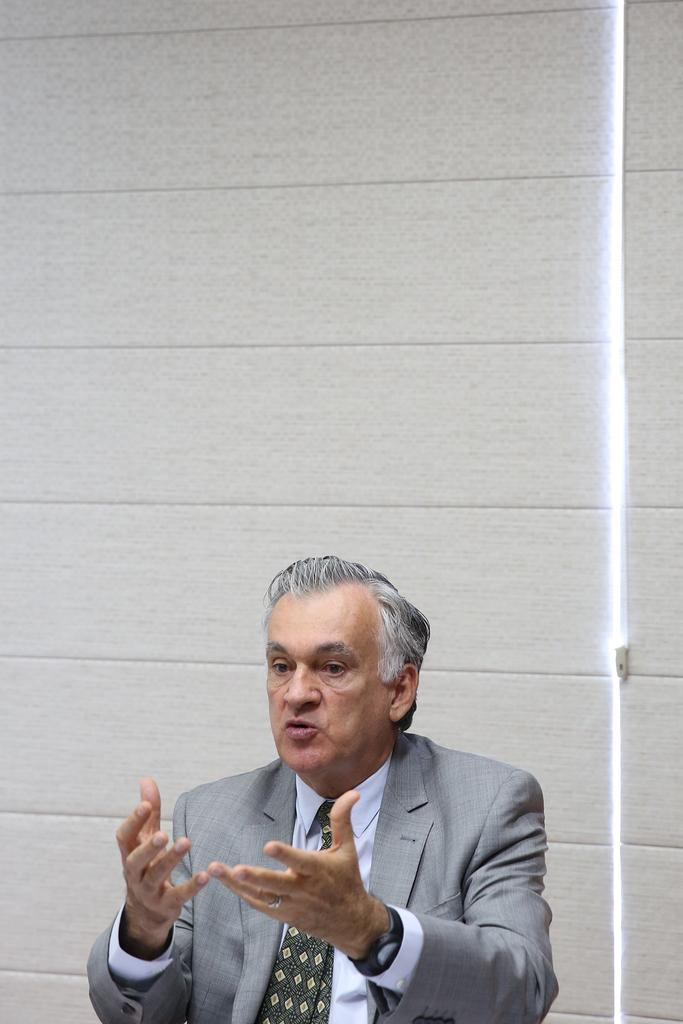Who is present in the image? There is a person in the image. What is the person wearing? The person is wearing a grey suit. What might the person be doing in the image? The person appears to be talking. What can be seen in the background of the image? There is a wall in the background of the image. How many hills can be seen in the image? There are no hills present in the image. What type of competition is the person participating in? There is no competition present in the image, and the person's activity is not specified as a competition. 